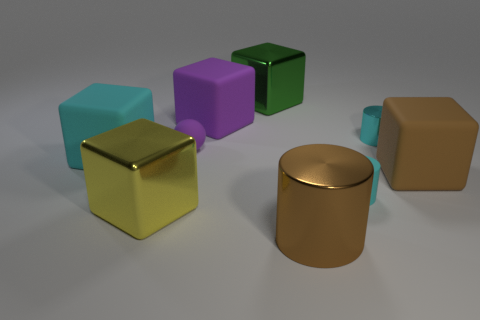Are there an equal number of rubber spheres that are to the right of the tiny sphere and big cylinders to the left of the big purple thing?
Provide a succinct answer. Yes. Are there any purple rubber spheres?
Make the answer very short. Yes. There is a matte block that is to the right of the small cyan cylinder behind the brown thing behind the yellow thing; what size is it?
Make the answer very short. Large. There is a purple matte thing that is the same size as the yellow metallic object; what is its shape?
Make the answer very short. Cube. Are there any other things that have the same material as the yellow block?
Ensure brevity in your answer.  Yes. How many things are blocks on the left side of the large purple object or purple rubber blocks?
Your response must be concise. 3. There is a large brown thing that is to the right of the tiny cylinder to the right of the tiny rubber cylinder; is there a tiny cyan rubber cylinder that is on the right side of it?
Make the answer very short. No. How many large yellow metal blocks are there?
Provide a short and direct response. 1. How many objects are either cyan cylinders that are behind the cyan matte cube or metal things that are in front of the big cyan cube?
Your response must be concise. 3. Is the size of the cyan object that is to the left of the green shiny object the same as the big purple rubber cube?
Make the answer very short. Yes. 